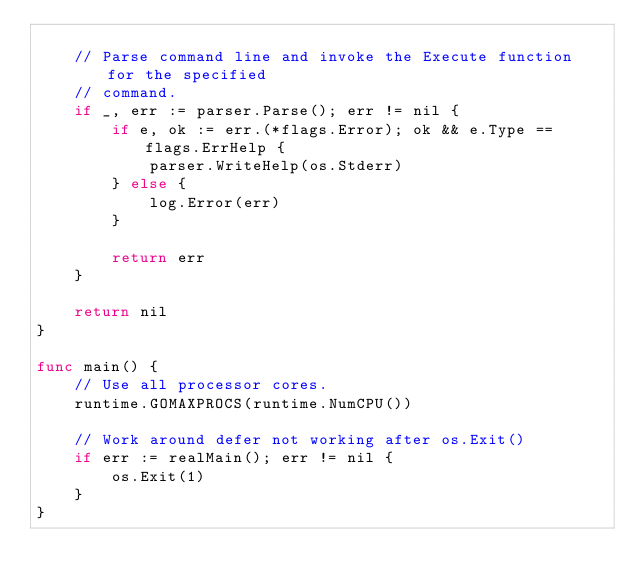<code> <loc_0><loc_0><loc_500><loc_500><_Go_>
	// Parse command line and invoke the Execute function for the specified
	// command.
	if _, err := parser.Parse(); err != nil {
		if e, ok := err.(*flags.Error); ok && e.Type == flags.ErrHelp {
			parser.WriteHelp(os.Stderr)
		} else {
			log.Error(err)
		}

		return err
	}

	return nil
}

func main() {
	// Use all processor cores.
	runtime.GOMAXPROCS(runtime.NumCPU())

	// Work around defer not working after os.Exit()
	if err := realMain(); err != nil {
		os.Exit(1)
	}
}
</code> 